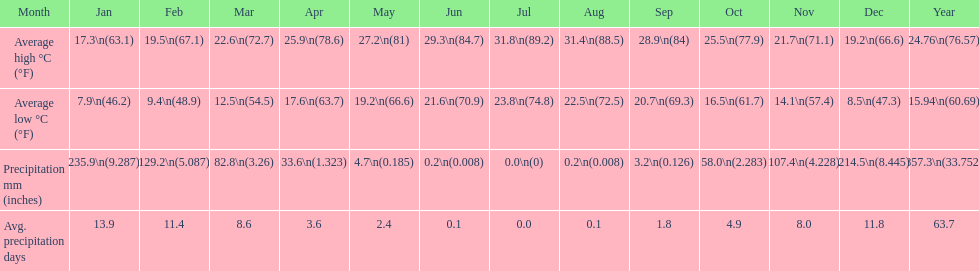Which month held the most precipitation? January. Can you parse all the data within this table? {'header': ['Month', 'Jan', 'Feb', 'Mar', 'Apr', 'May', 'Jun', 'Jul', 'Aug', 'Sep', 'Oct', 'Nov', 'Dec', 'Year'], 'rows': [['Average high °C (°F)', '17.3\\n(63.1)', '19.5\\n(67.1)', '22.6\\n(72.7)', '25.9\\n(78.6)', '27.2\\n(81)', '29.3\\n(84.7)', '31.8\\n(89.2)', '31.4\\n(88.5)', '28.9\\n(84)', '25.5\\n(77.9)', '21.7\\n(71.1)', '19.2\\n(66.6)', '24.76\\n(76.57)'], ['Average low °C (°F)', '7.9\\n(46.2)', '9.4\\n(48.9)', '12.5\\n(54.5)', '17.6\\n(63.7)', '19.2\\n(66.6)', '21.6\\n(70.9)', '23.8\\n(74.8)', '22.5\\n(72.5)', '20.7\\n(69.3)', '16.5\\n(61.7)', '14.1\\n(57.4)', '8.5\\n(47.3)', '15.94\\n(60.69)'], ['Precipitation mm (inches)', '235.9\\n(9.287)', '129.2\\n(5.087)', '82.8\\n(3.26)', '33.6\\n(1.323)', '4.7\\n(0.185)', '0.2\\n(0.008)', '0.0\\n(0)', '0.2\\n(0.008)', '3.2\\n(0.126)', '58.0\\n(2.283)', '107.4\\n(4.228)', '214.5\\n(8.445)', '857.3\\n(33.752)'], ['Avg. precipitation days', '13.9', '11.4', '8.6', '3.6', '2.4', '0.1', '0.0', '0.1', '1.8', '4.9', '8.0', '11.8', '63.7']]} 